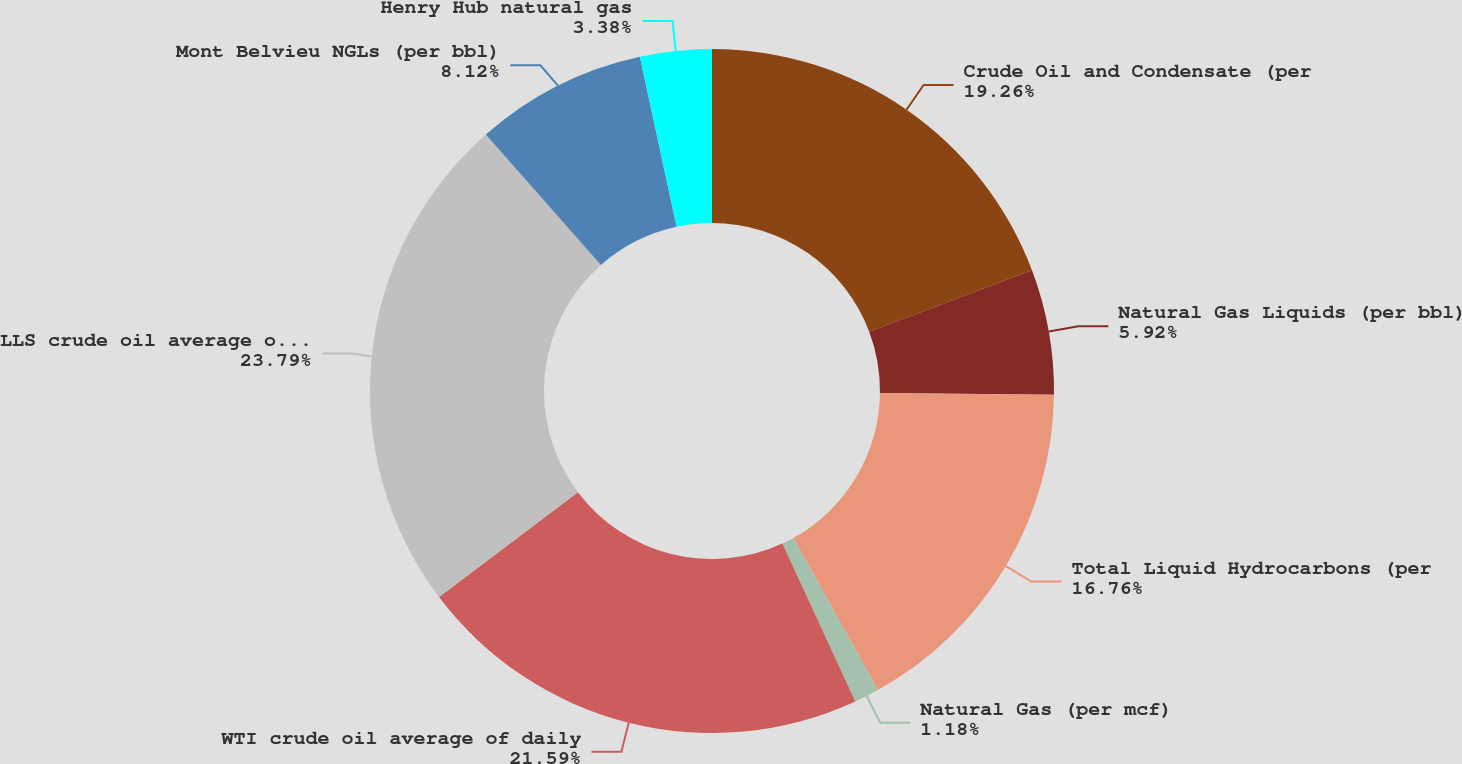Convert chart. <chart><loc_0><loc_0><loc_500><loc_500><pie_chart><fcel>Crude Oil and Condensate (per<fcel>Natural Gas Liquids (per bbl)<fcel>Total Liquid Hydrocarbons (per<fcel>Natural Gas (per mcf)<fcel>WTI crude oil average of daily<fcel>LLS crude oil average of daily<fcel>Mont Belvieu NGLs (per bbl)<fcel>Henry Hub natural gas<nl><fcel>19.26%<fcel>5.92%<fcel>16.76%<fcel>1.18%<fcel>21.59%<fcel>23.79%<fcel>8.12%<fcel>3.38%<nl></chart> 